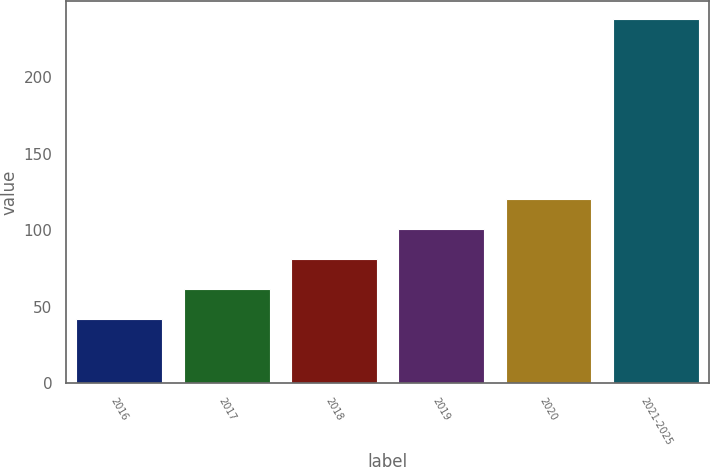<chart> <loc_0><loc_0><loc_500><loc_500><bar_chart><fcel>2016<fcel>2017<fcel>2018<fcel>2019<fcel>2020<fcel>2021-2025<nl><fcel>42<fcel>61.6<fcel>81.2<fcel>100.8<fcel>120.4<fcel>238<nl></chart> 